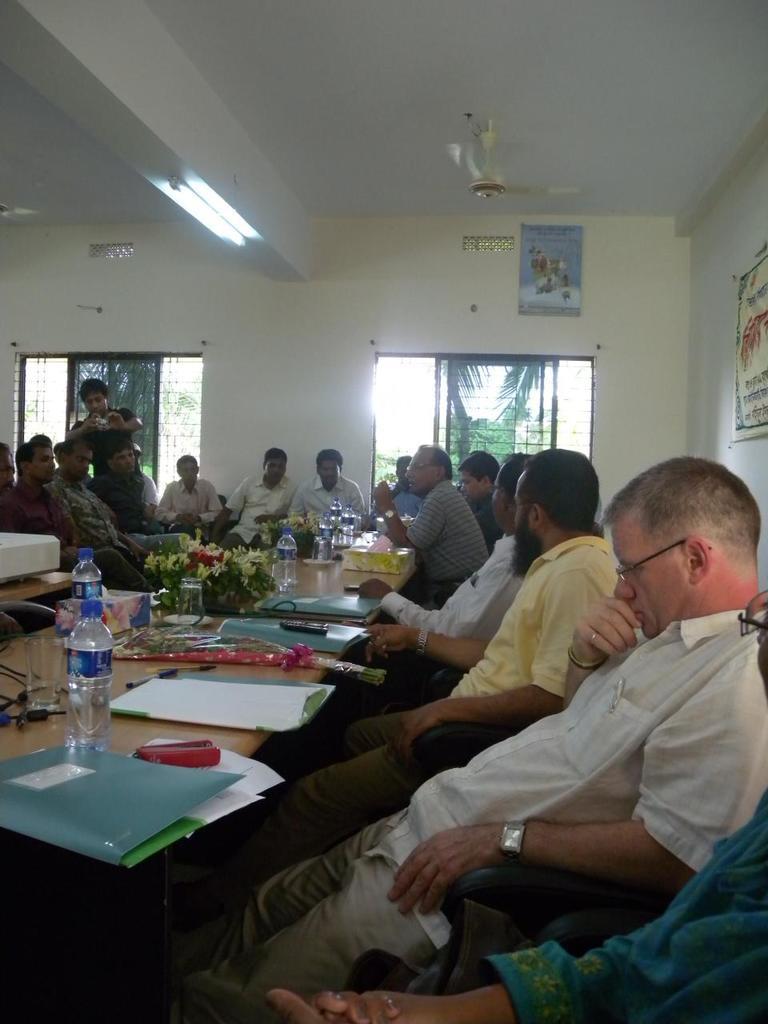In one or two sentences, can you explain what this image depicts? In this picture there are people sitting and have a table in front of them which has some water bottles and files 